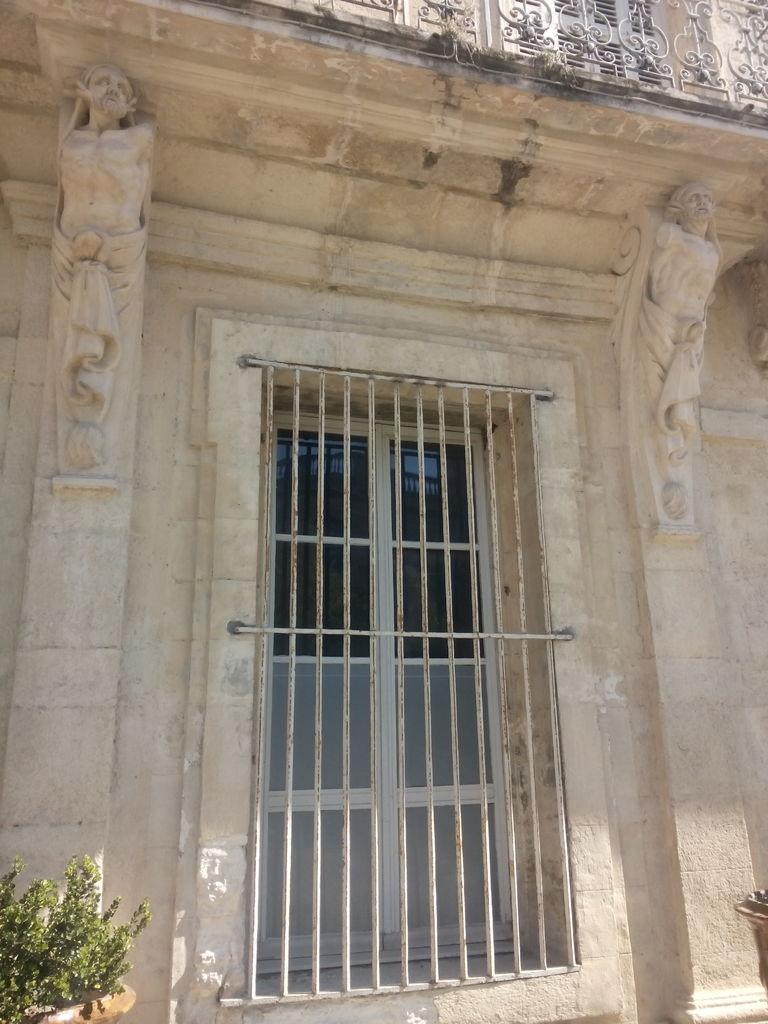How would you summarize this image in a sentence or two? In the image there is a window and on the either side of the window there are two sculptures made to the wall and on the left side there is a plant. 